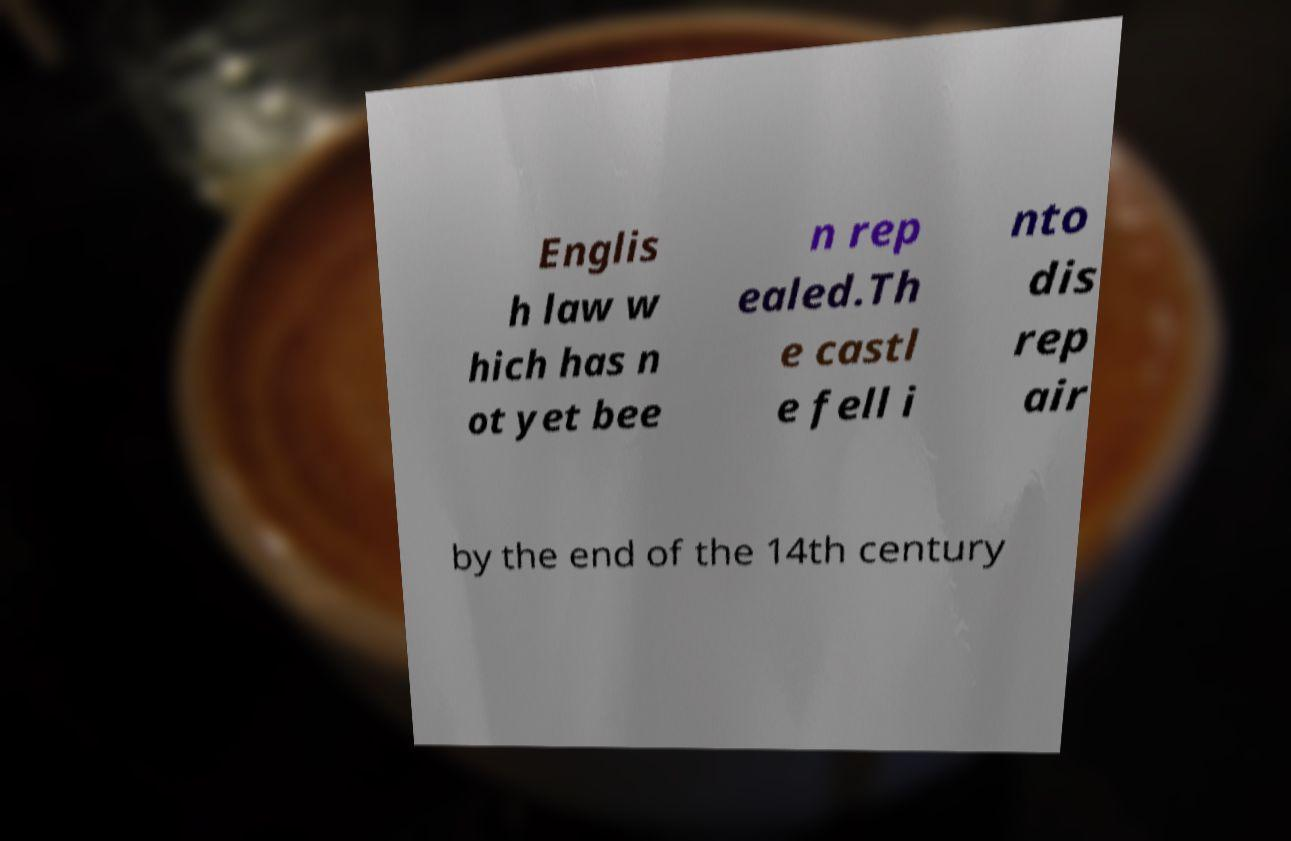Can you accurately transcribe the text from the provided image for me? Englis h law w hich has n ot yet bee n rep ealed.Th e castl e fell i nto dis rep air by the end of the 14th century 